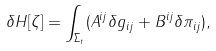Convert formula to latex. <formula><loc_0><loc_0><loc_500><loc_500>\delta H [ \zeta ] = \int _ { \Sigma _ { t } } ( A ^ { i j } \delta g _ { i j } + B ^ { i j } \delta \pi _ { i j } ) ,</formula> 